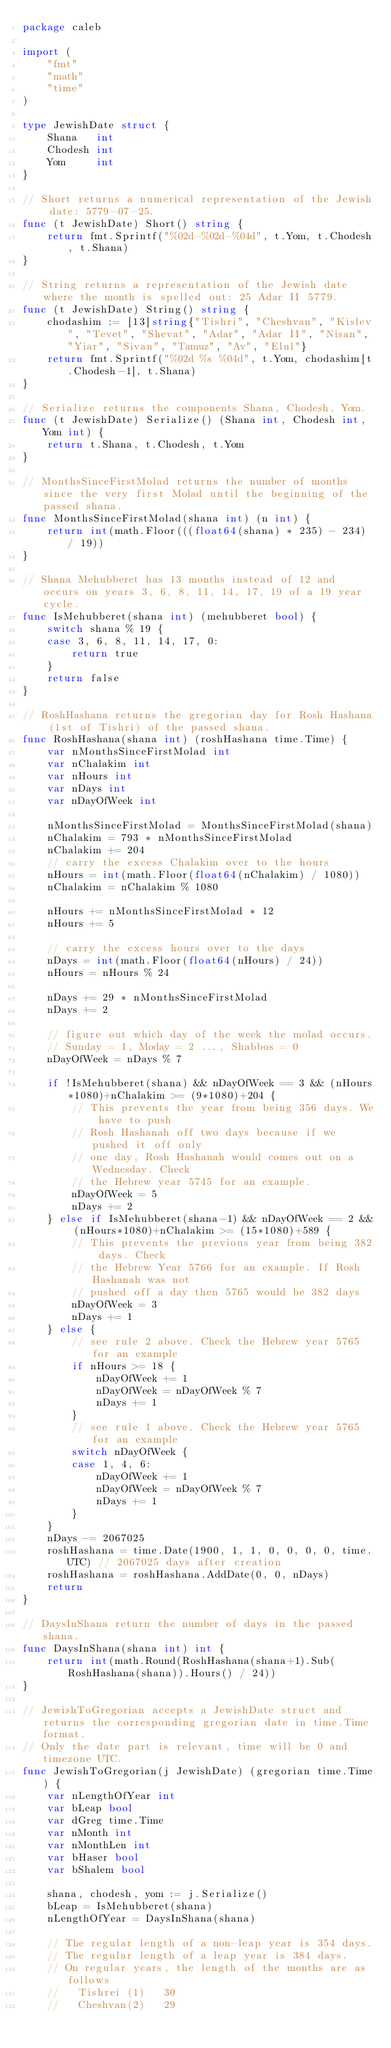<code> <loc_0><loc_0><loc_500><loc_500><_Go_>package caleb

import (
	"fmt"
	"math"
	"time"
)

type JewishDate struct {
	Shana   int
	Chodesh int
	Yom     int
}

// Short returns a numerical representation of the Jewish date: 5779-07-25.
func (t JewishDate) Short() string {
	return fmt.Sprintf("%02d-%02d-%04d", t.Yom, t.Chodesh, t.Shana)
}

// String returns a representation of the Jewish date where the month is spelled out: 25 Adar II 5779.
func (t JewishDate) String() string {
	chodashim := [13]string{"Tishri", "Cheshvan", "Kislev", "Tevet", "Shevat", "Adar", "Adar II", "Nisan", "Yiar", "Sivan", "Tamuz", "Av", "Elul"}
	return fmt.Sprintf("%02d %s %04d", t.Yom, chodashim[t.Chodesh-1], t.Shana)
}

// Serialize returns the components Shana, Chodesh, Yom.
func (t JewishDate) Serialize() (Shana int, Chodesh int, Yom int) {
	return t.Shana, t.Chodesh, t.Yom
}

// MonthsSinceFirstMolad returns the number of months since the very first Molad until the beginning of the passed shana.
func MonthsSinceFirstMolad(shana int) (n int) {
	return int(math.Floor(((float64(shana) * 235) - 234) / 19))
}

// Shana Mehubberet has 13 months instead of 12 and occurs on years 3, 6, 8, 11, 14, 17, 19 of a 19 year cycle.
func IsMehubberet(shana int) (mehubberet bool) {
	switch shana % 19 {
	case 3, 6, 8, 11, 14, 17, 0:
		return true
	}
	return false
}

// RoshHashana returns the gregorian day for Rosh Hashana (1st of Tishri) of the passed shana.
func RoshHashana(shana int) (roshHashana time.Time) {
	var nMonthsSinceFirstMolad int
	var nChalakim int
	var nHours int
	var nDays int
	var nDayOfWeek int

	nMonthsSinceFirstMolad = MonthsSinceFirstMolad(shana)
	nChalakim = 793 * nMonthsSinceFirstMolad
	nChalakim += 204
	// carry the excess Chalakim over to the hours
	nHours = int(math.Floor(float64(nChalakim) / 1080))
	nChalakim = nChalakim % 1080

	nHours += nMonthsSinceFirstMolad * 12
	nHours += 5

	// carry the excess hours over to the days
	nDays = int(math.Floor(float64(nHours) / 24))
	nHours = nHours % 24

	nDays += 29 * nMonthsSinceFirstMolad
	nDays += 2

	// figure out which day of the week the molad occurs.
	// Sunday = 1, Moday = 2 ..., Shabbos = 0
	nDayOfWeek = nDays % 7

	if !IsMehubberet(shana) && nDayOfWeek == 3 && (nHours*1080)+nChalakim >= (9*1080)+204 {
		// This prevents the year from being 356 days. We have to push
		// Rosh Hashanah off two days because if we pushed it off only
		// one day, Rosh Hashanah would comes out on a Wednesday. Check
		// the Hebrew year 5745 for an example.
		nDayOfWeek = 5
		nDays += 2
	} else if IsMehubberet(shana-1) && nDayOfWeek == 2 && (nHours*1080)+nChalakim >= (15*1080)+589 {
		// This prevents the previous year from being 382 days. Check
		// the Hebrew Year 5766 for an example. If Rosh Hashanah was not
		// pushed off a day then 5765 would be 382 days
		nDayOfWeek = 3
		nDays += 1
	} else {
		// see rule 2 above. Check the Hebrew year 5765 for an example
		if nHours >= 18 {
			nDayOfWeek += 1
			nDayOfWeek = nDayOfWeek % 7
			nDays += 1
		}
		// see rule 1 above. Check the Hebrew year 5765 for an example
		switch nDayOfWeek {
		case 1, 4, 6:
			nDayOfWeek += 1
			nDayOfWeek = nDayOfWeek % 7
			nDays += 1
		}
	}
	nDays -= 2067025
	roshHashana = time.Date(1900, 1, 1, 0, 0, 0, 0, time.UTC) // 2067025 days after creation
	roshHashana = roshHashana.AddDate(0, 0, nDays)
	return
}

// DaysInShana return the number of days in the passed shana.
func DaysInShana(shana int) int {
	return int(math.Round(RoshHashana(shana+1).Sub(RoshHashana(shana)).Hours() / 24))
}

// JewishToGregorian accepts a JewishDate struct and returns the corresponding gregorian date in time.Time format.
// Only the date part is relevant, time will be 0 and timezone UTC.
func JewishToGregorian(j JewishDate) (gregorian time.Time) {
	var nLengthOfYear int
	var bLeap bool
	var dGreg time.Time
	var nMonth int
	var nMonthLen int
	var bHaser bool
	var bShalem bool

	shana, chodesh, yom := j.Serialize()
	bLeap = IsMehubberet(shana)
	nLengthOfYear = DaysInShana(shana)

	// The regular length of a non-leap year is 354 days.
	// The regular length of a leap year is 384 days.
	// On regular years, the length of the months are as follows
	//   Tishrei (1)   30
	//   Cheshvan(2)   29</code> 